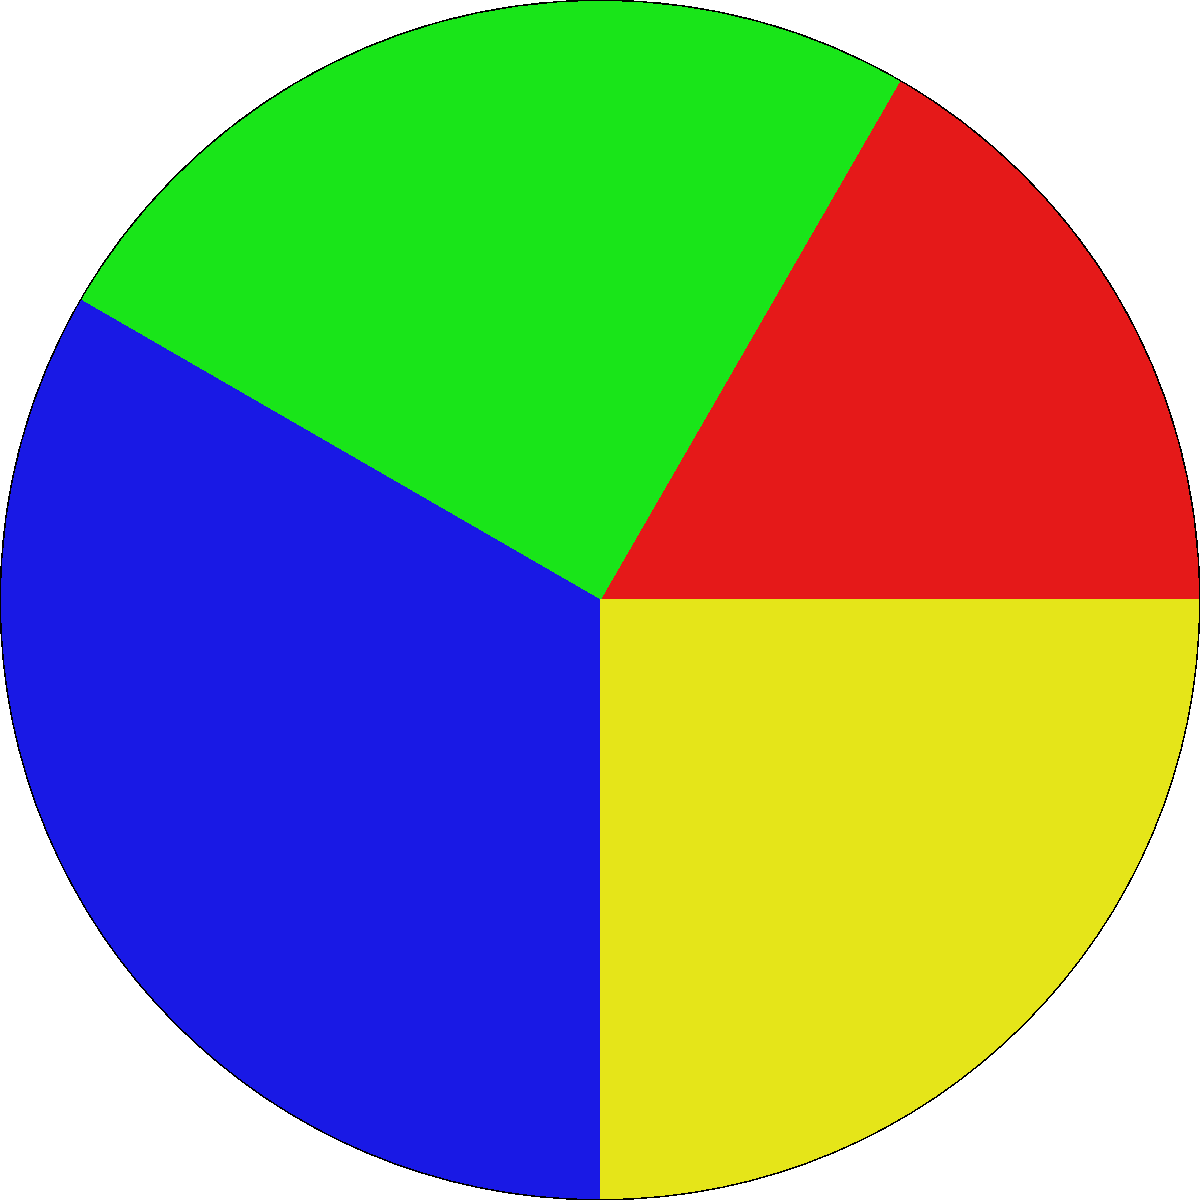In a Salesforce multi-app deployment, storage space is allocated as shown in the circular chart. The CRM app currently occupies 30% of the total space. If the total storage capacity is 1000 GB and you need to increase the CRM app's allocation by 20% of its current size, how much additional storage (in GB) needs to be allocated to the CRM app? To solve this problem, let's follow these steps:

1. Calculate the current storage allocation for the CRM app:
   * Total storage = 1000 GB
   * CRM app's current allocation = 30% of 1000 GB
   * CRM app's current allocation = $0.30 \times 1000 \text{ GB} = 300 \text{ GB}$

2. Calculate the required increase:
   * Increase needed = 20% of current allocation
   * Increase = $0.20 \times 300 \text{ GB} = 60 \text{ GB}$

Therefore, an additional 60 GB of storage needs to be allocated to the CRM app to increase its allocation by 20% of its current size.
Answer: 60 GB 